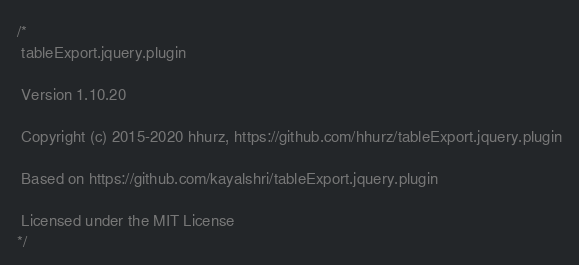<code> <loc_0><loc_0><loc_500><loc_500><_JavaScript_>/*
 tableExport.jquery.plugin

 Version 1.10.20

 Copyright (c) 2015-2020 hhurz, https://github.com/hhurz/tableExport.jquery.plugin

 Based on https://github.com/kayalshri/tableExport.jquery.plugin

 Licensed under the MIT License
*/</code> 